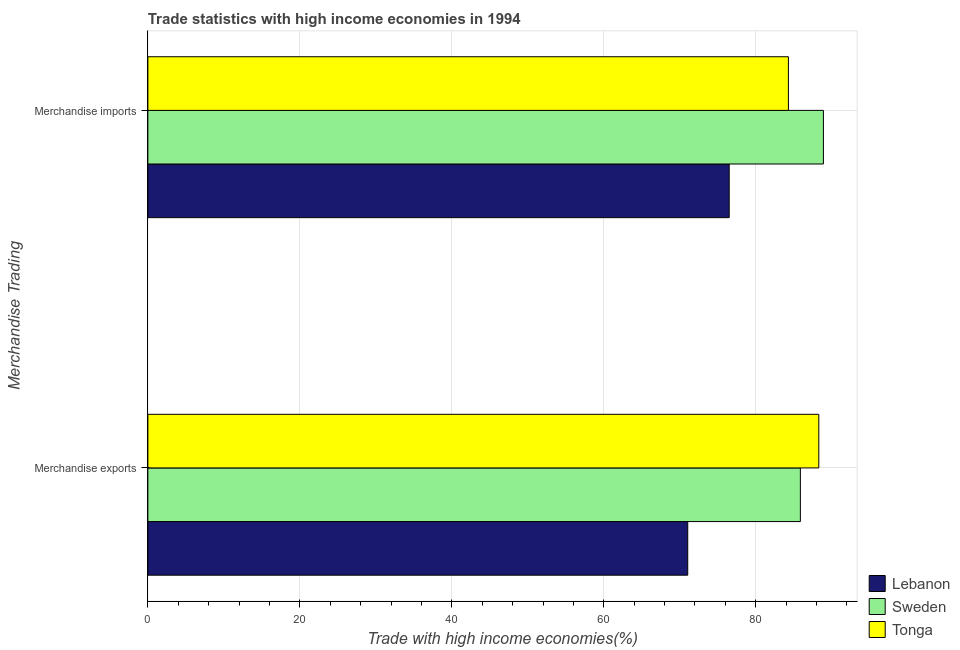How many different coloured bars are there?
Ensure brevity in your answer.  3. How many groups of bars are there?
Offer a terse response. 2. How many bars are there on the 2nd tick from the top?
Keep it short and to the point. 3. What is the label of the 1st group of bars from the top?
Keep it short and to the point. Merchandise imports. What is the merchandise exports in Sweden?
Your response must be concise. 85.87. Across all countries, what is the maximum merchandise imports?
Provide a short and direct response. 88.9. Across all countries, what is the minimum merchandise exports?
Provide a short and direct response. 71.05. In which country was the merchandise exports maximum?
Your answer should be compact. Tonga. In which country was the merchandise imports minimum?
Keep it short and to the point. Lebanon. What is the total merchandise imports in the graph?
Offer a terse response. 249.7. What is the difference between the merchandise exports in Tonga and that in Lebanon?
Give a very brief answer. 17.25. What is the difference between the merchandise imports in Sweden and the merchandise exports in Lebanon?
Ensure brevity in your answer.  17.86. What is the average merchandise imports per country?
Your answer should be very brief. 83.23. What is the difference between the merchandise exports and merchandise imports in Lebanon?
Ensure brevity in your answer.  -5.46. In how many countries, is the merchandise imports greater than 64 %?
Ensure brevity in your answer.  3. What is the ratio of the merchandise exports in Lebanon to that in Sweden?
Ensure brevity in your answer.  0.83. What does the 2nd bar from the top in Merchandise imports represents?
Make the answer very short. Sweden. What does the 3rd bar from the bottom in Merchandise imports represents?
Your answer should be compact. Tonga. Are all the bars in the graph horizontal?
Offer a very short reply. Yes. Does the graph contain grids?
Your response must be concise. Yes. What is the title of the graph?
Your answer should be compact. Trade statistics with high income economies in 1994. What is the label or title of the X-axis?
Your answer should be very brief. Trade with high income economies(%). What is the label or title of the Y-axis?
Ensure brevity in your answer.  Merchandise Trading. What is the Trade with high income economies(%) in Lebanon in Merchandise exports?
Offer a very short reply. 71.05. What is the Trade with high income economies(%) of Sweden in Merchandise exports?
Make the answer very short. 85.87. What is the Trade with high income economies(%) of Tonga in Merchandise exports?
Your answer should be compact. 88.29. What is the Trade with high income economies(%) of Lebanon in Merchandise imports?
Keep it short and to the point. 76.5. What is the Trade with high income economies(%) in Sweden in Merchandise imports?
Provide a short and direct response. 88.9. What is the Trade with high income economies(%) in Tonga in Merchandise imports?
Make the answer very short. 84.3. Across all Merchandise Trading, what is the maximum Trade with high income economies(%) of Lebanon?
Keep it short and to the point. 76.5. Across all Merchandise Trading, what is the maximum Trade with high income economies(%) in Sweden?
Offer a very short reply. 88.9. Across all Merchandise Trading, what is the maximum Trade with high income economies(%) in Tonga?
Provide a short and direct response. 88.29. Across all Merchandise Trading, what is the minimum Trade with high income economies(%) in Lebanon?
Offer a very short reply. 71.05. Across all Merchandise Trading, what is the minimum Trade with high income economies(%) in Sweden?
Keep it short and to the point. 85.87. Across all Merchandise Trading, what is the minimum Trade with high income economies(%) in Tonga?
Your response must be concise. 84.3. What is the total Trade with high income economies(%) of Lebanon in the graph?
Ensure brevity in your answer.  147.55. What is the total Trade with high income economies(%) of Sweden in the graph?
Your answer should be very brief. 174.77. What is the total Trade with high income economies(%) in Tonga in the graph?
Give a very brief answer. 172.59. What is the difference between the Trade with high income economies(%) of Lebanon in Merchandise exports and that in Merchandise imports?
Provide a succinct answer. -5.46. What is the difference between the Trade with high income economies(%) in Sweden in Merchandise exports and that in Merchandise imports?
Give a very brief answer. -3.03. What is the difference between the Trade with high income economies(%) in Tonga in Merchandise exports and that in Merchandise imports?
Ensure brevity in your answer.  4. What is the difference between the Trade with high income economies(%) of Lebanon in Merchandise exports and the Trade with high income economies(%) of Sweden in Merchandise imports?
Provide a succinct answer. -17.86. What is the difference between the Trade with high income economies(%) in Lebanon in Merchandise exports and the Trade with high income economies(%) in Tonga in Merchandise imports?
Provide a short and direct response. -13.25. What is the difference between the Trade with high income economies(%) of Sweden in Merchandise exports and the Trade with high income economies(%) of Tonga in Merchandise imports?
Your answer should be very brief. 1.58. What is the average Trade with high income economies(%) in Lebanon per Merchandise Trading?
Offer a very short reply. 73.78. What is the average Trade with high income economies(%) of Sweden per Merchandise Trading?
Offer a terse response. 87.39. What is the average Trade with high income economies(%) in Tonga per Merchandise Trading?
Your response must be concise. 86.3. What is the difference between the Trade with high income economies(%) in Lebanon and Trade with high income economies(%) in Sweden in Merchandise exports?
Offer a terse response. -14.82. What is the difference between the Trade with high income economies(%) in Lebanon and Trade with high income economies(%) in Tonga in Merchandise exports?
Ensure brevity in your answer.  -17.25. What is the difference between the Trade with high income economies(%) of Sweden and Trade with high income economies(%) of Tonga in Merchandise exports?
Keep it short and to the point. -2.42. What is the difference between the Trade with high income economies(%) in Lebanon and Trade with high income economies(%) in Sweden in Merchandise imports?
Your answer should be compact. -12.4. What is the difference between the Trade with high income economies(%) of Lebanon and Trade with high income economies(%) of Tonga in Merchandise imports?
Your answer should be very brief. -7.79. What is the difference between the Trade with high income economies(%) of Sweden and Trade with high income economies(%) of Tonga in Merchandise imports?
Your response must be concise. 4.61. What is the ratio of the Trade with high income economies(%) in Lebanon in Merchandise exports to that in Merchandise imports?
Provide a succinct answer. 0.93. What is the ratio of the Trade with high income economies(%) in Sweden in Merchandise exports to that in Merchandise imports?
Give a very brief answer. 0.97. What is the ratio of the Trade with high income economies(%) in Tonga in Merchandise exports to that in Merchandise imports?
Make the answer very short. 1.05. What is the difference between the highest and the second highest Trade with high income economies(%) of Lebanon?
Offer a terse response. 5.46. What is the difference between the highest and the second highest Trade with high income economies(%) in Sweden?
Your answer should be compact. 3.03. What is the difference between the highest and the second highest Trade with high income economies(%) of Tonga?
Keep it short and to the point. 4. What is the difference between the highest and the lowest Trade with high income economies(%) of Lebanon?
Provide a short and direct response. 5.46. What is the difference between the highest and the lowest Trade with high income economies(%) in Sweden?
Keep it short and to the point. 3.03. What is the difference between the highest and the lowest Trade with high income economies(%) of Tonga?
Offer a very short reply. 4. 